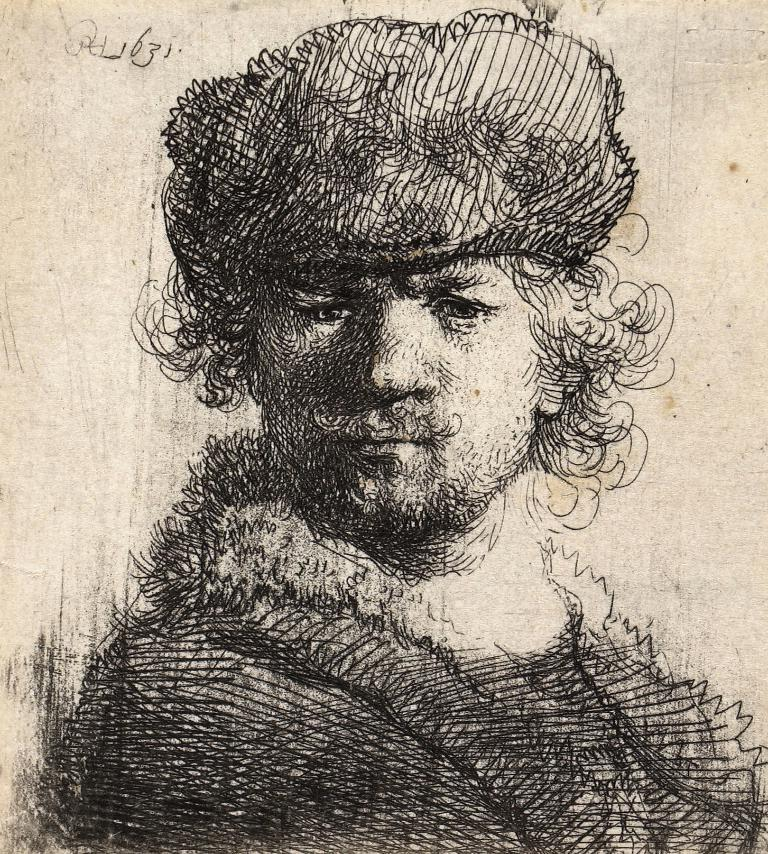What is the main subject of the image? The image contains an art piece. What does the art piece depict? The art piece depicts a man. What type of cloth is being used to create steam in the image? There is no cloth or steam present in the image; it contains an art piece depicting a man. 